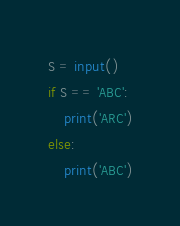<code> <loc_0><loc_0><loc_500><loc_500><_Python_>S = input()
if S == 'ABC':
    print('ARC')
else:
    print('ABC')</code> 